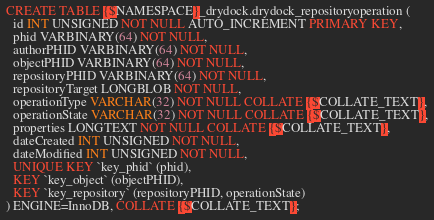<code> <loc_0><loc_0><loc_500><loc_500><_SQL_>CREATE TABLE {$NAMESPACE}_drydock.drydock_repositoryoperation (
  id INT UNSIGNED NOT NULL AUTO_INCREMENT PRIMARY KEY,
  phid VARBINARY(64) NOT NULL,
  authorPHID VARBINARY(64) NOT NULL,
  objectPHID VARBINARY(64) NOT NULL,
  repositoryPHID VARBINARY(64) NOT NULL,
  repositoryTarget LONGBLOB NOT NULL,
  operationType VARCHAR(32) NOT NULL COLLATE {$COLLATE_TEXT},
  operationState VARCHAR(32) NOT NULL COLLATE {$COLLATE_TEXT},
  properties LONGTEXT NOT NULL COLLATE {$COLLATE_TEXT},
  dateCreated INT UNSIGNED NOT NULL,
  dateModified INT UNSIGNED NOT NULL,
  UNIQUE KEY `key_phid` (phid),
  KEY `key_object` (objectPHID),
  KEY `key_repository` (repositoryPHID, operationState)
) ENGINE=InnoDB, COLLATE {$COLLATE_TEXT};
</code> 